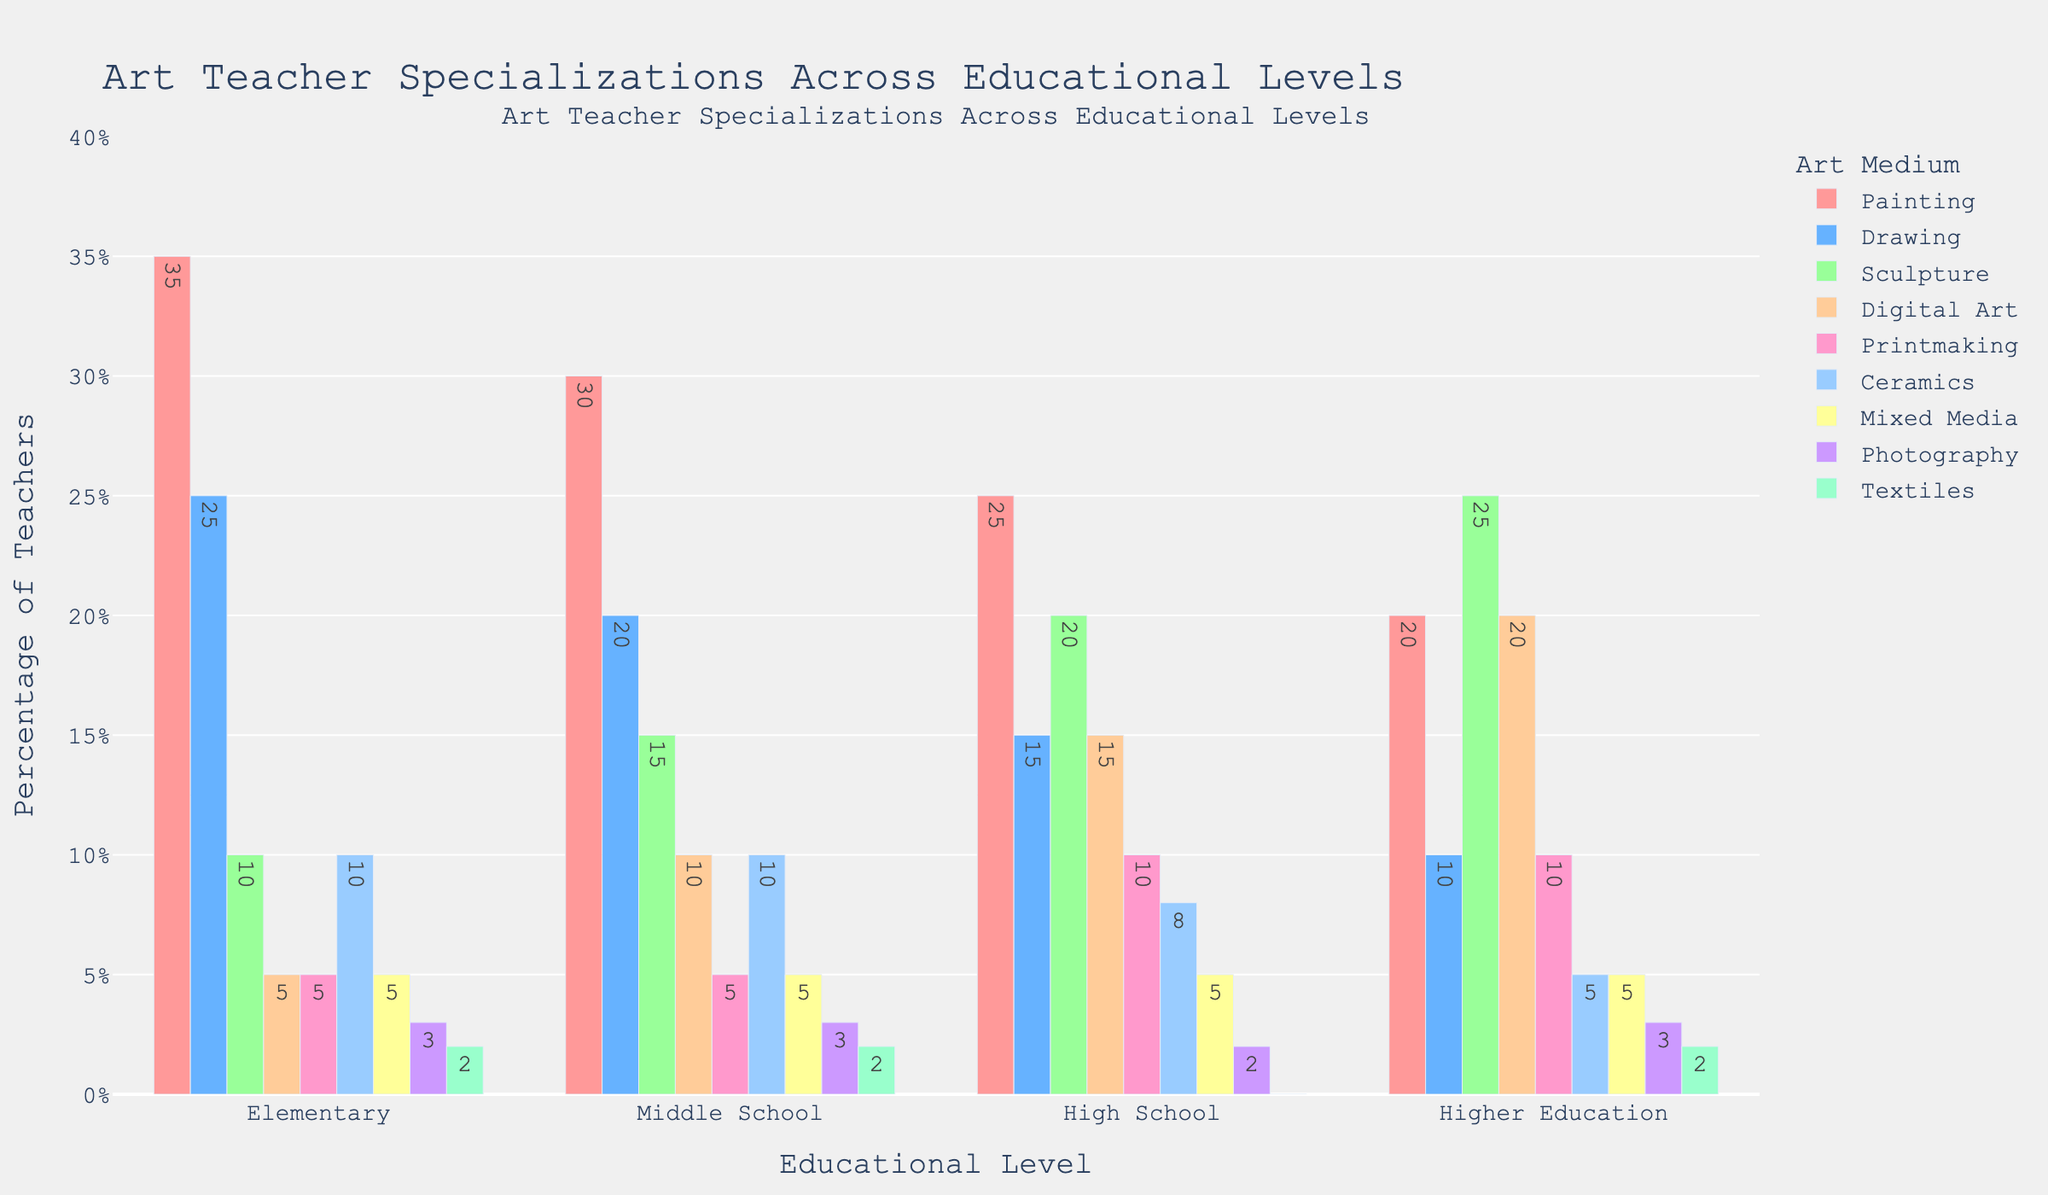Which medium has the highest percentage of art teachers at the elementary level? By looking at the bar heights for the elementary level, the tallest bar represents the medium with the highest percentage. For the elementary level, the highest bar is labeled "Painting" with a percentage of 35%.
Answer: Painting Which medium shows a consistent percentage of art teachers across all educational levels? To find a consistent percentage, observe the bars for a medium that remains the same across all educational levels. The bars for "Mixed Media" are all at 5%, indicating consistency.
Answer: Mixed Media What is the total percentage of art teachers specializing in Painting across all educational levels? Sum the percentages of art teachers specializing in Painting for each educational level: 35% (Elementary) + 30% (Middle School) + 25% (High School) + 20% (Higher Education) = 110%.
Answer: 110% Compare the percentage of art teachers specializing in Sculpture between high school and higher education. Which level has more, and by how much? Look at the heights of the bars for Sculpture. At high school, it is 20%, and at higher education, it is 25%. The difference is 25% - 20% = 5%, with higher education having more.
Answer: Higher education, by 5% Which two mediums combined have the same percentage as the Painting medium at the middle school level? Painting at the middle school level is 30%. We'll look for two mediums whose combined percentage at that level is 30%. "Sculpture" (15%) and "Digital Art" (10%) sum up to 25%, and "Ceramics" (10%) and "Drawing" (20%) sum up to 30%.
Answer: Drawing and Ceramics Which educational level has the least percentage of text-based media (Drawing, Printmaking, and Textiles) teachers overall, and what is the combined percentage? Calculate combined percentages for each level: 
- Elementary: Drawing (25%) + Printmaking (5%) + Textiles (2%) = 32%
- Middle School: Drawing (20%) + Printmaking (5%) + Textiles (2%) = 27%
- High School: Drawing (15%) + Printmaking (10%) + Textiles (0%) = 25%
- Higher Education: Drawing (10%) + Printmaking (10%) + Textiles (2%) = 22%
The least combined percentage is at higher education with 22%.
Answer: Higher Education, 22% How does the percentage of Digital Art teachers change from elementary to higher education? Track the bar heights of Digital Art across levels. The percentages are: 5% (Elementary), 10% (Middle School), 15% (High School), and 20% (Higher Education). The change can be noted as: 
Elementary to Middle School: +5%
Middle School to High School: +5%
High School to Higher Education: +5%
The percentage consistently increases by 5% at each level.
Answer: Increases by 5% at each level 